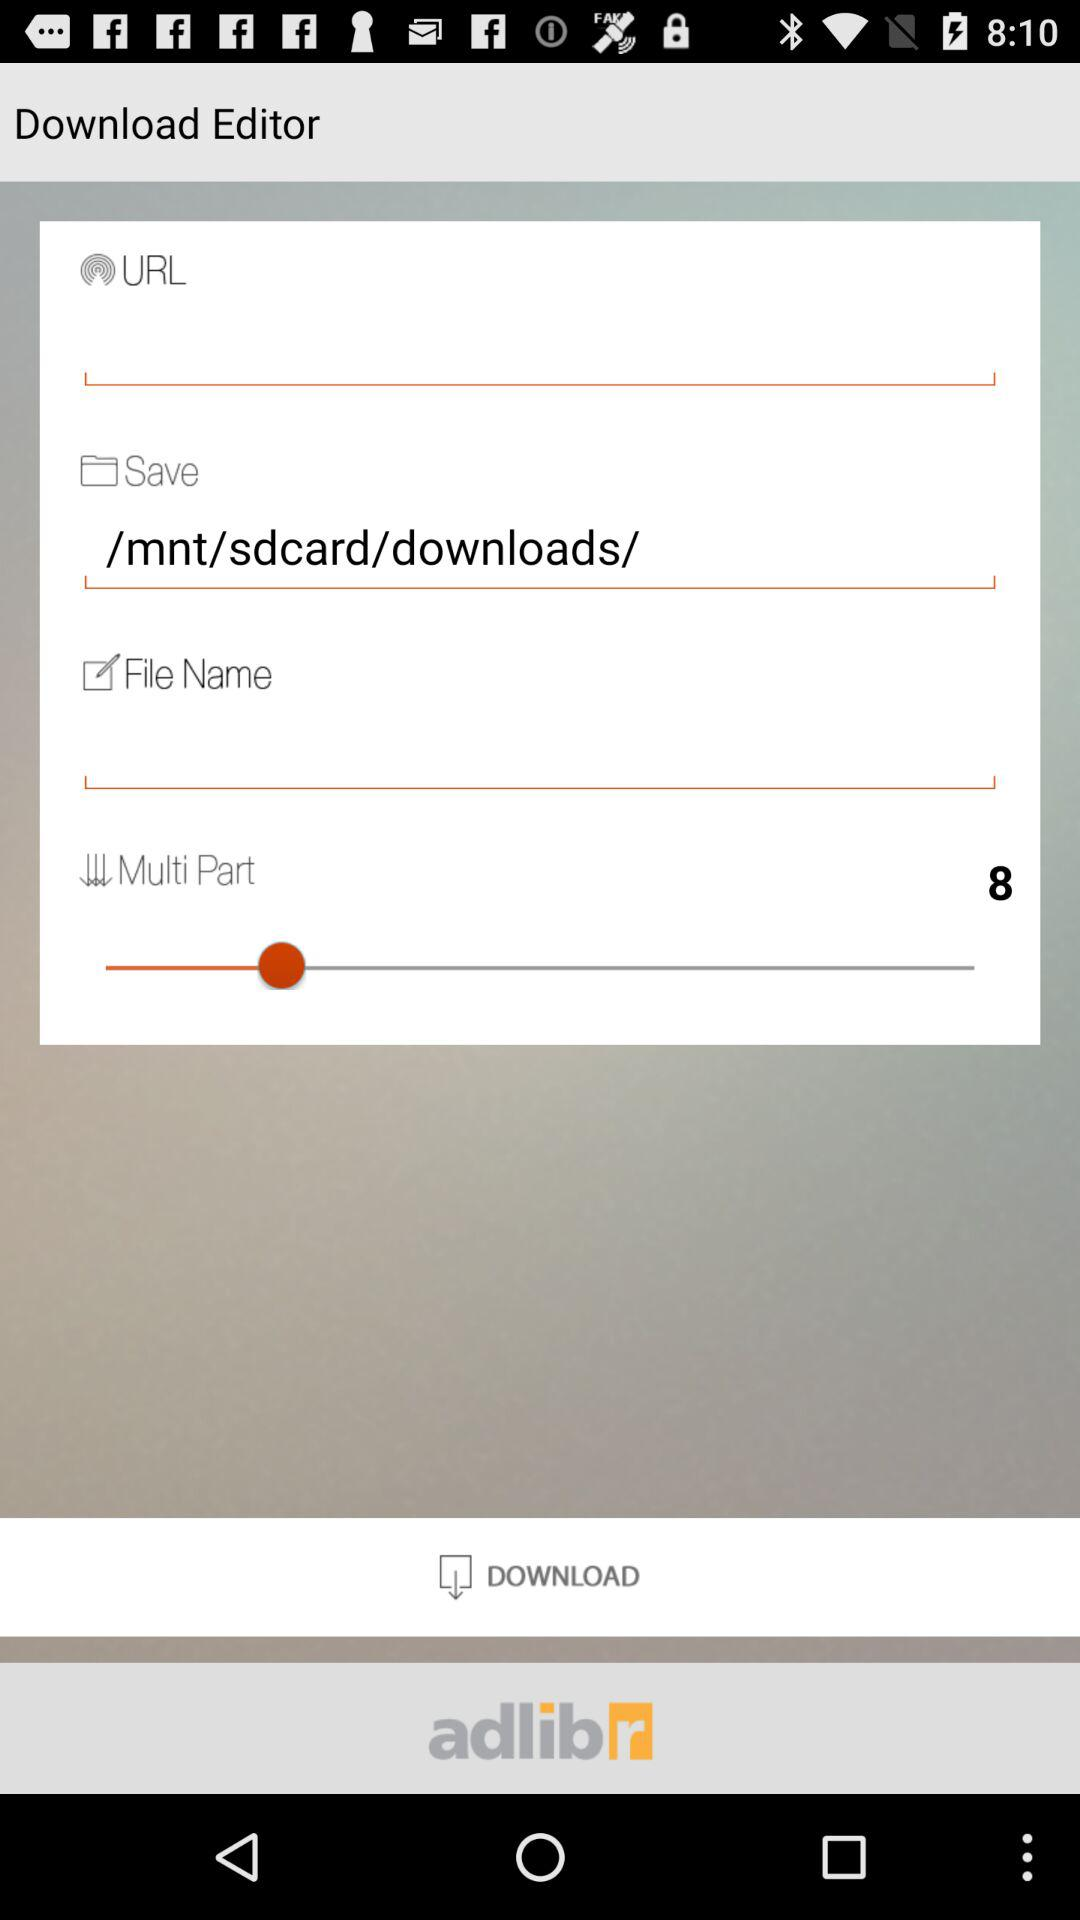How many multi parts are there? There are 8 multi parts. 